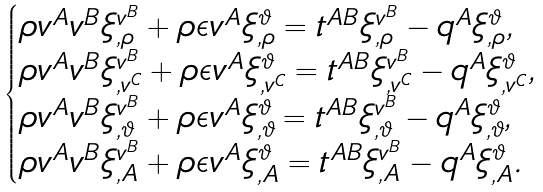<formula> <loc_0><loc_0><loc_500><loc_500>\begin{cases} \rho v ^ { A } v ^ { B } \xi ^ { v ^ { B } } _ { , \rho } + \rho \epsilon v ^ { A } \xi ^ { \vartheta } _ { , \rho } = t ^ { A B } \xi ^ { v ^ { B } } _ { , \rho } - q ^ { A } \xi ^ { \vartheta } _ { , \rho } , \\ \rho v ^ { A } v ^ { B } \xi ^ { v ^ { B } } _ { , v ^ { C } } + \rho \epsilon v ^ { A } \xi ^ { \vartheta } _ { , v ^ { C } } = t ^ { A B } \xi ^ { v ^ { B } } _ { , v ^ { C } } - q ^ { A } \xi ^ { \vartheta } _ { , v ^ { C } } , \\ \rho v ^ { A } v ^ { B } \xi ^ { v ^ { B } } _ { , \vartheta } + \rho \epsilon v ^ { A } \xi ^ { \vartheta } _ { , \vartheta } = t ^ { A B } \xi ^ { v ^ { B } } _ { , \vartheta } - q ^ { A } \xi ^ { \vartheta } _ { , \vartheta } , \\ \rho v ^ { A } v ^ { B } \xi ^ { v ^ { B } } _ { , A } + \rho \epsilon v ^ { A } \xi ^ { \vartheta } _ { , A } = t ^ { A B } \xi ^ { v ^ { B } } _ { , A } - q ^ { A } \xi ^ { \vartheta } _ { , A } . \end{cases}</formula> 